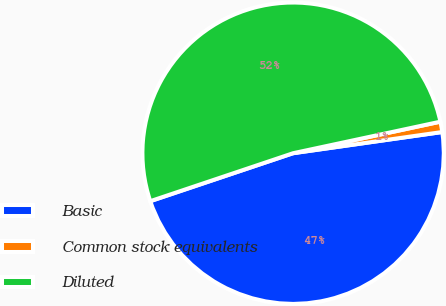<chart> <loc_0><loc_0><loc_500><loc_500><pie_chart><fcel>Basic<fcel>Common stock equivalents<fcel>Diluted<nl><fcel>47.09%<fcel>1.11%<fcel>51.8%<nl></chart> 